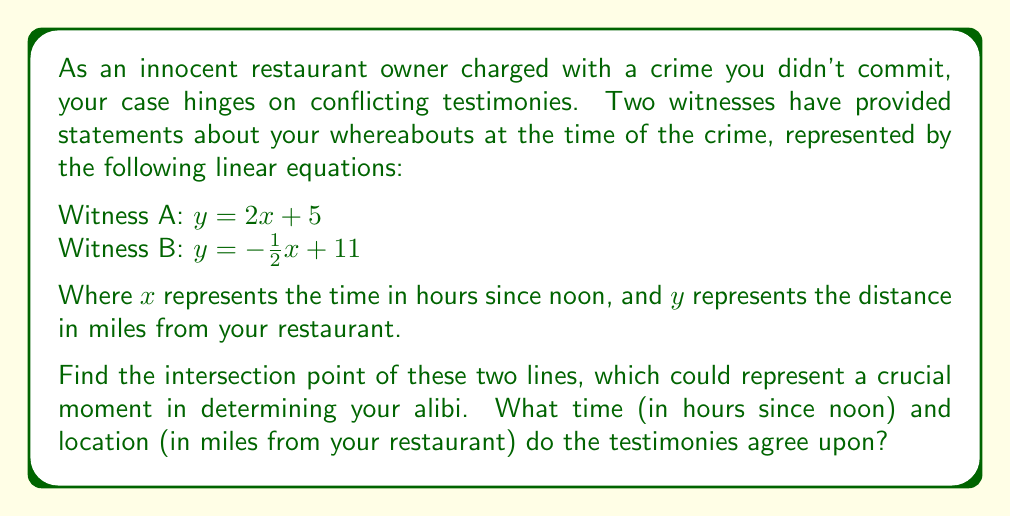Could you help me with this problem? To find the intersection point of two lines, we need to solve the system of equations:

$$\begin{cases} 
y = 2x + 5 \\
y = -\frac{1}{2}x + 11
\end{cases}$$

1) Since both equations are equal to $y$, we can set them equal to each other:

   $2x + 5 = -\frac{1}{2}x + 11$

2) Add $\frac{1}{2}x$ to both sides:

   $\frac{5}{2}x + 5 = 11$

3) Subtract 5 from both sides:

   $\frac{5}{2}x = 6$

4) Multiply both sides by $\frac{2}{5}$:

   $x = \frac{12}{5} = 2.4$

5) Now that we know $x$, we can substitute it into either of the original equations to find $y$. Let's use the first equation:

   $y = 2(2.4) + 5 = 4.8 + 5 = 9.8$

Therefore, the intersection point is $(2.4, 9.8)$.

This means the testimonies agree that you were 9.8 miles from your restaurant 2.4 hours after noon (which is 2:24 PM).
Answer: The testimonies intersect at the point (2.4, 9.8), meaning they agree that you were 9.8 miles from your restaurant at 2:24 PM. 